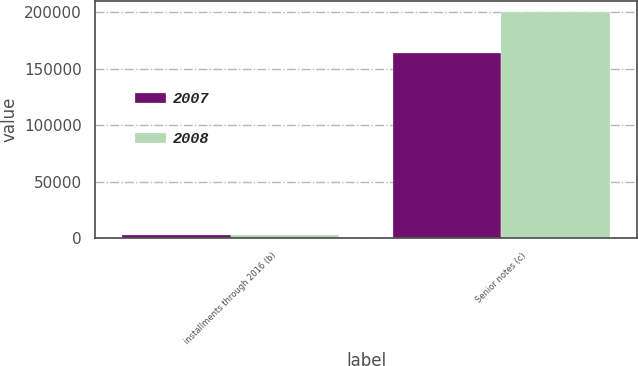Convert chart. <chart><loc_0><loc_0><loc_500><loc_500><stacked_bar_chart><ecel><fcel>installments through 2016 (b)<fcel>Senior notes (c)<nl><fcel>2007<fcel>2530<fcel>163320<nl><fcel>2008<fcel>2820<fcel>200000<nl></chart> 